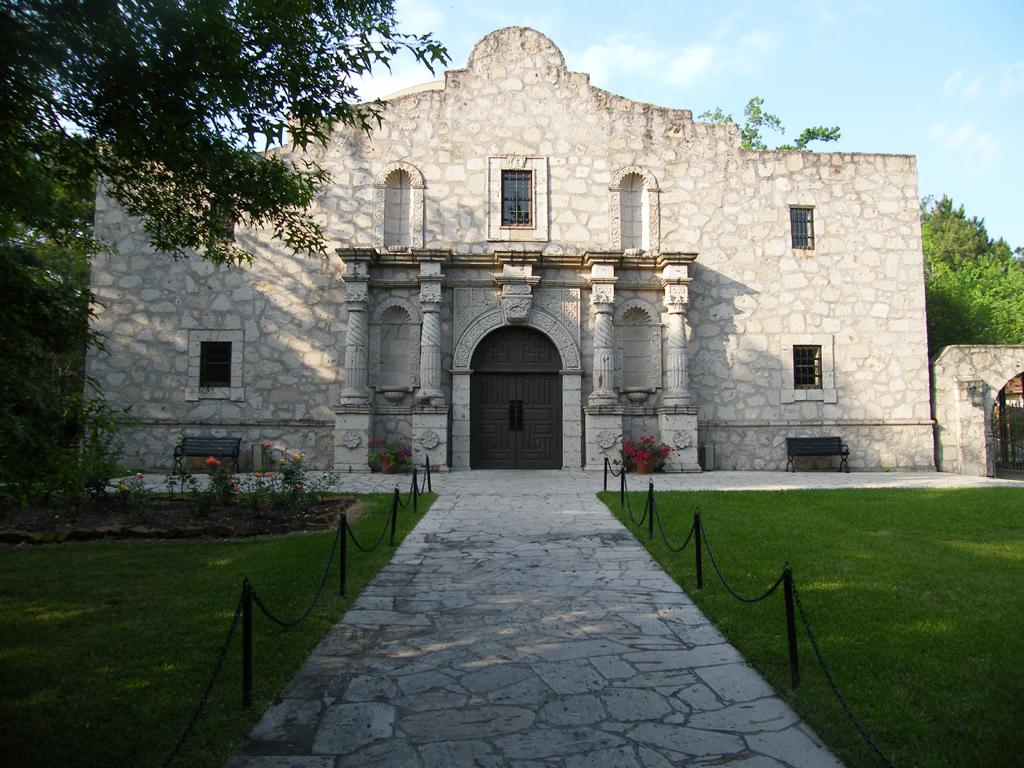What is the main structure visible in the image? There is a building in the front of the image. What surrounds the building on either side? There is a garden on either side of the building. What can be seen in the distance behind the building? There are trees in the background of the image. What type of locket can be seen hanging from the tree in the image? There is no locket present in the image; it only features a building, gardens, and trees. 